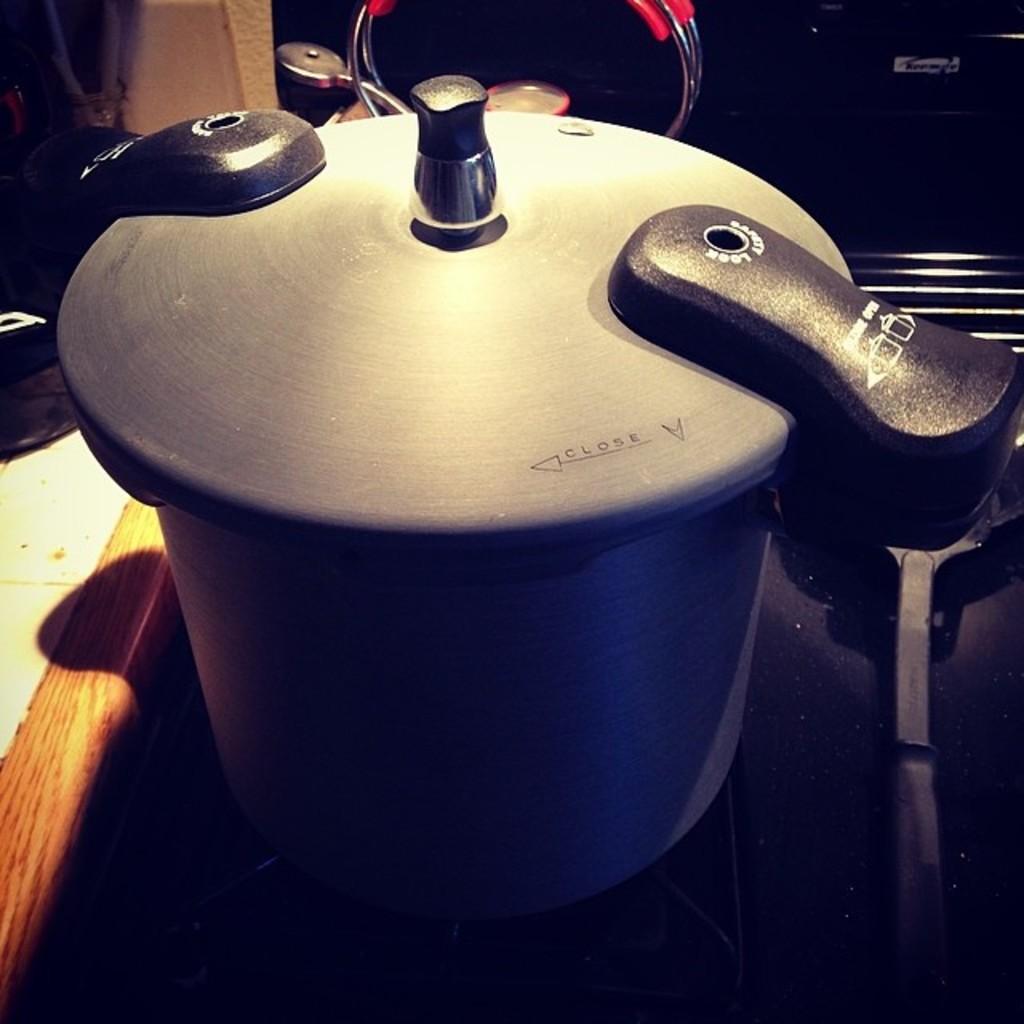Which way do you turn the top to close it?
Your answer should be compact. Left. What is printed around the hole on the right handle?
Provide a short and direct response. Unanswerable. 